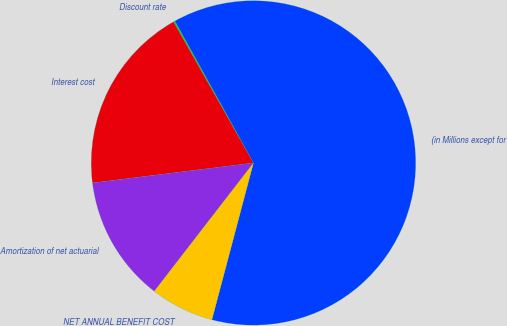Convert chart to OTSL. <chart><loc_0><loc_0><loc_500><loc_500><pie_chart><fcel>(in Millions except for<fcel>Discount rate<fcel>Interest cost<fcel>Amortization of net actuarial<fcel>NET ANNUAL BENEFIT COST<nl><fcel>62.18%<fcel>0.15%<fcel>18.76%<fcel>12.56%<fcel>6.35%<nl></chart> 